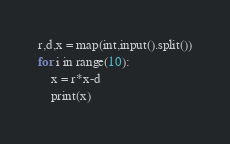Convert code to text. <code><loc_0><loc_0><loc_500><loc_500><_Python_>r,d,x = map(int,input().split())
for i in range(10):
    x = r*x-d
    print(x)</code> 